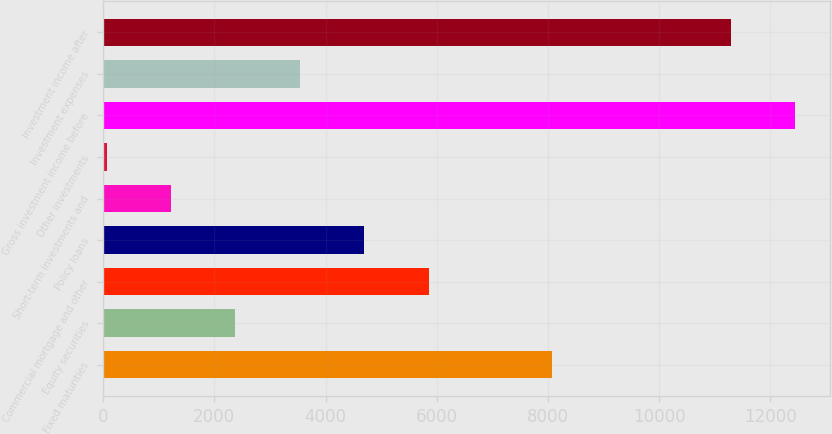Convert chart. <chart><loc_0><loc_0><loc_500><loc_500><bar_chart><fcel>Fixed maturities<fcel>Equity securities<fcel>Commercial mortgage and other<fcel>Policy loans<fcel>Short-term investments and<fcel>Other investments<fcel>Gross investment income before<fcel>Investment expenses<fcel>Investment income after<nl><fcel>8073<fcel>2381.4<fcel>5854.5<fcel>4696.8<fcel>1223.7<fcel>66<fcel>12442.7<fcel>3539.1<fcel>11285<nl></chart> 